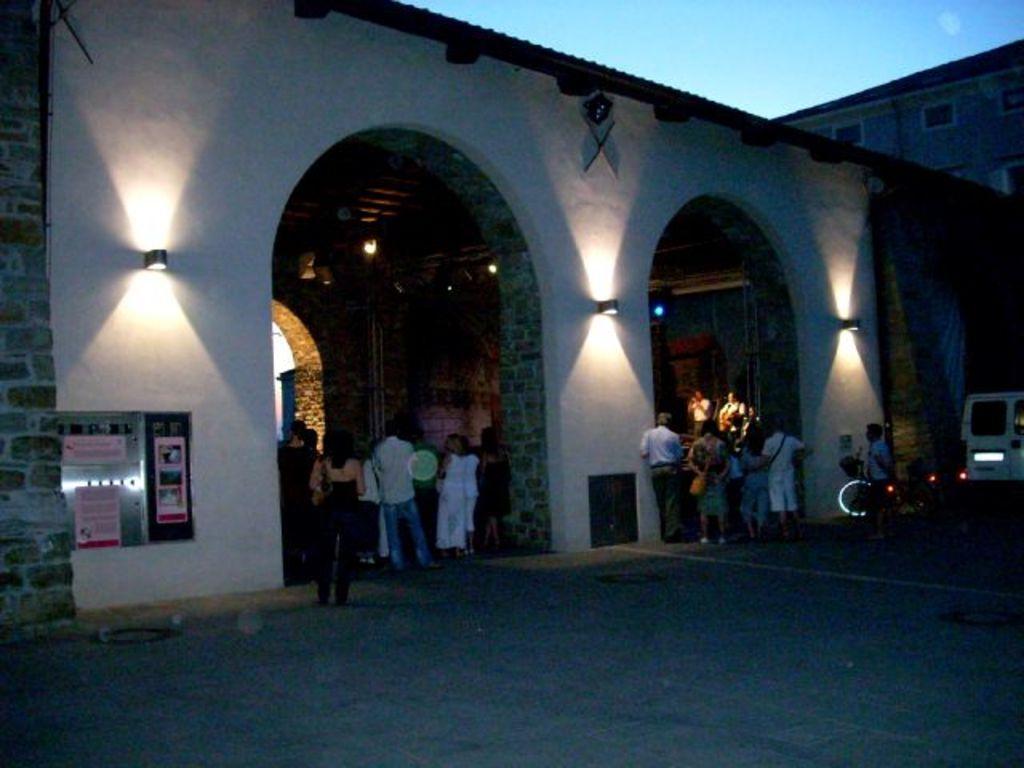In one or two sentences, can you explain what this image depicts? In this image I can see few persons standing, background I can see a vehicle in white color and I can see few buildings in white and cream color and I can also see few lights. 